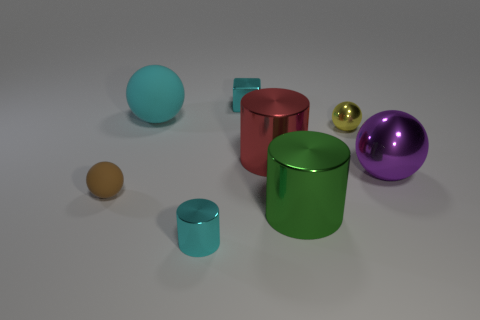Is there anything else that has the same color as the small matte sphere? Upon reviewing the image, it seems that there are no other objects that share the exact color and finish with the small matte sphere. 